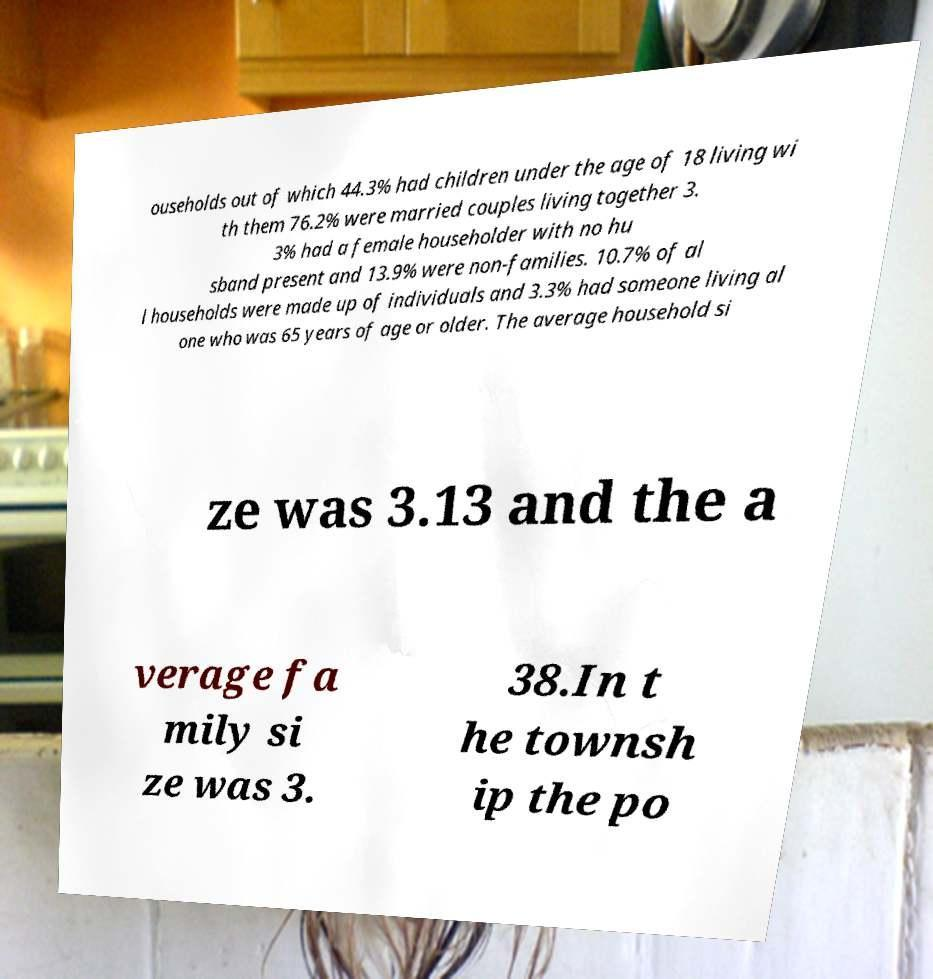For documentation purposes, I need the text within this image transcribed. Could you provide that? ouseholds out of which 44.3% had children under the age of 18 living wi th them 76.2% were married couples living together 3. 3% had a female householder with no hu sband present and 13.9% were non-families. 10.7% of al l households were made up of individuals and 3.3% had someone living al one who was 65 years of age or older. The average household si ze was 3.13 and the a verage fa mily si ze was 3. 38.In t he townsh ip the po 